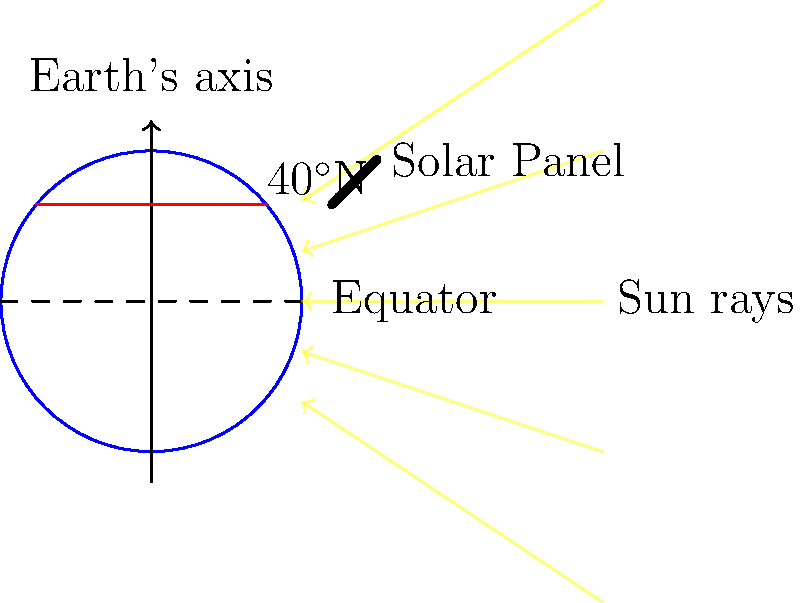Based on the sun path diagram shown for a location at 40°N latitude, what is the optimal tilt angle for a fixed solar panel to maximize annual energy production, and in which direction should it face? To determine the optimal tilt angle and orientation for a fixed solar panel at 40°N latitude, we need to consider several factors:

1. Latitude: The general rule of thumb is that the optimal tilt angle is approximately equal to the latitude of the location. This is because the average sun position throughout the year is closest to this angle.

2. Seasonal variations: The sun's path changes throughout the year. In summer, it's higher in the sky, while in winter, it's lower.

3. Energy demand: Sometimes, the optimal angle might be adjusted slightly to favor winter production if energy demand is higher in winter months.

4. Direction: In the Northern Hemisphere, solar panels should face true south to receive maximum sunlight throughout the day.

5. Fine-tuning: The exact optimal angle can be further refined based on local climate data and energy demand patterns.

For a location at 40°N latitude:

1. The starting point for the tilt angle would be 40°.
2. A slight adjustment might be made to favor winter production, typically by adding 10-15°.
3. Therefore, an optimal tilt angle would be between 40° and 55°.
4. The panel should face true south.

In practice, 45° is often used as it's a good compromise and easy to implement.
Answer: 45° tilt, facing true south 